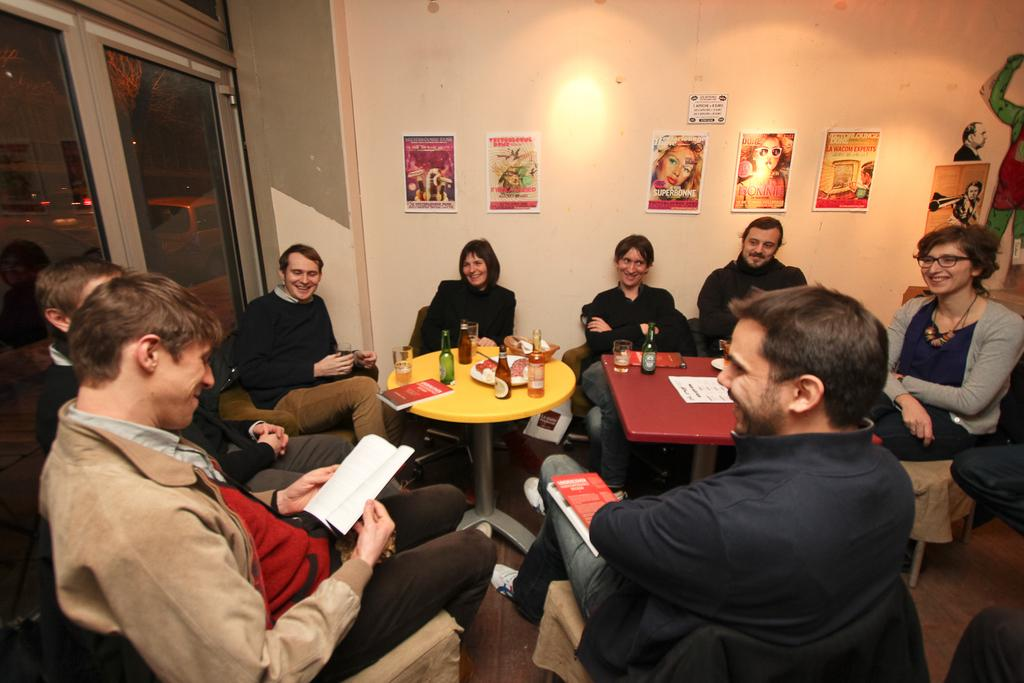What are the people in the image doing? There is a group of people sitting on chairs in the image. What objects can be seen on the table? There is a bottle and a glass on the table in the image. What is attached to the wall in the image? There are pamphlets attached to the wall in the image. What type of jelly can be seen on the chairs in the image? There is no jelly present on the chairs in the image. How does the organization of the people in the image contribute to their productivity? The image does not provide information about the organization of the people or their productivity. 